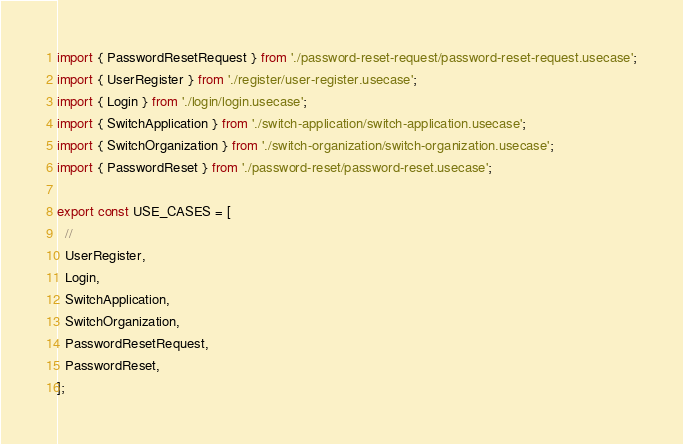<code> <loc_0><loc_0><loc_500><loc_500><_TypeScript_>import { PasswordResetRequest } from './password-reset-request/password-reset-request.usecase';
import { UserRegister } from './register/user-register.usecase';
import { Login } from './login/login.usecase';
import { SwitchApplication } from './switch-application/switch-application.usecase';
import { SwitchOrganization } from './switch-organization/switch-organization.usecase';
import { PasswordReset } from './password-reset/password-reset.usecase';

export const USE_CASES = [
  //
  UserRegister,
  Login,
  SwitchApplication,
  SwitchOrganization,
  PasswordResetRequest,
  PasswordReset,
];
</code> 